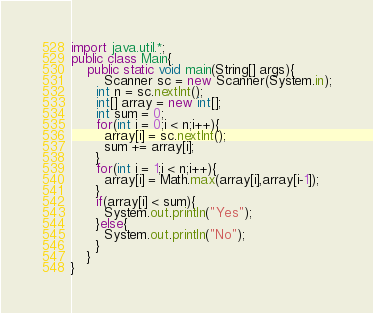<code> <loc_0><loc_0><loc_500><loc_500><_Java_>import java.util.*;
public class Main{
	public static void main(String[] args){
    	Scanner sc = new Scanner(System.in);
      int n = sc.nextInt();
      int[] array = new int[];
      int sum = 0;
      for(int i = 0;i < n;i++){
      	array[i] = sc.nextInt();
        sum += array[i];
      }
      for(int i = 1;i < n;i++){
      	array[i] = Math.max(array[i],array[i-1]);
      }
      if(array[i] < sum){
      	System.out.println("Yes");
      }else{
      	System.out.println("No");
      }
    }
}</code> 